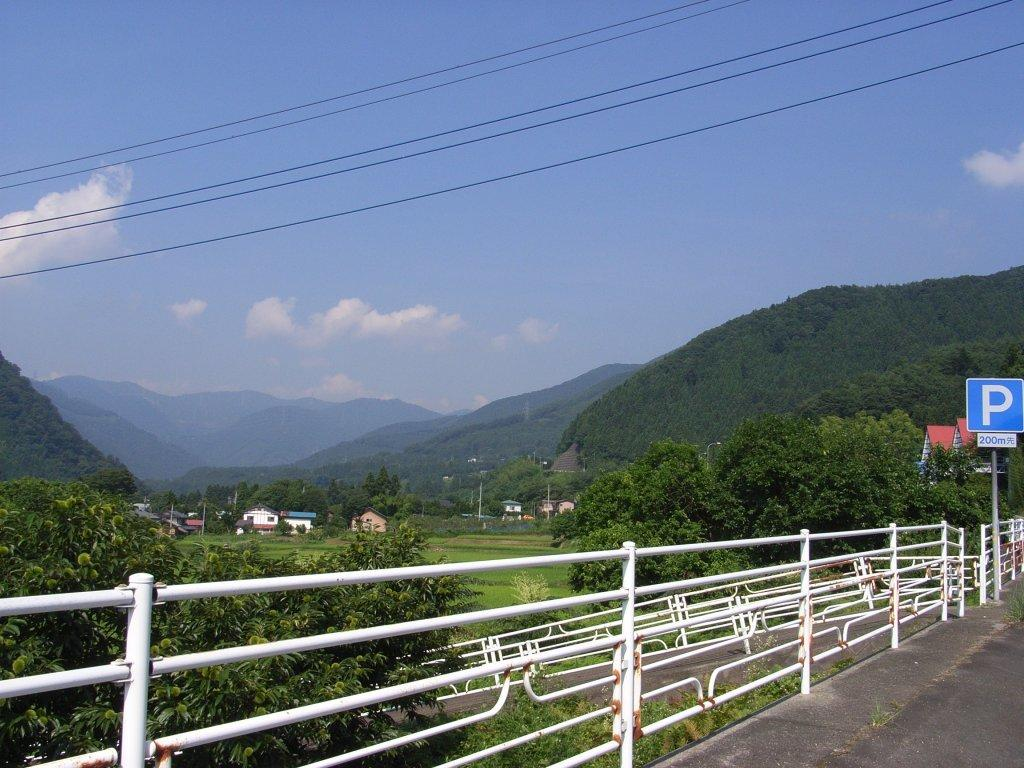What is the main feature of the image? There is a road in the image. What can be seen alongside the road? There is a white color railing in the image. What type of natural elements are present in the image? There are trees in the image. What type of man-made structures can be seen in the image? There are houses in the image. What is visible in the background of the image? Hills and the sky are visible in the background of the image. What is the condition of the sky in the image? The sky is visible in the background of the image, and there are clouds in the sky. What type of butter is being used to grease the car's tires in the image? There is no car or butter present in the image. How many chickens can be seen running across the road in the image? There are no chickens visible in the image. 